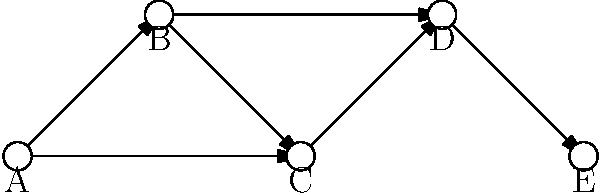Based on the neural network diagram representing emotional regulation pathways identified through DTI, which node is most likely to represent the amygdala, given its central role in emotional processing and its connections to other regions? To answer this question, we need to analyze the network structure and our knowledge of emotional regulation pathways:

1. The amygdala is a key structure in emotional processing and regulation.
2. It has extensive connections with other brain regions involved in emotional regulation.
3. In the diagram, we're looking for a node with multiple connections, particularly ones that appear central to the network.

Analyzing the nodes:
A: Has two outgoing connections, could be an input region.
B: Has one incoming and two outgoing connections.
C: Has two incoming and one outgoing connection, appears central.
D: Has two incoming and one outgoing connection.
E: Has one incoming connection, likely an output region.

Node C appears to be the most centrally located and has multiple connections (two incoming, one outgoing). This pattern is consistent with the amygdala's role in receiving input from various regions, processing emotional information, and sending output to other areas involved in emotional responses.

Given its position and connections, node C is most likely to represent the amygdala in this simplified network of emotional regulation pathways.
Answer: C 